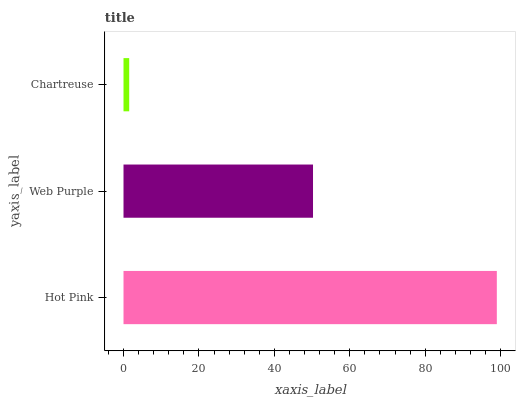Is Chartreuse the minimum?
Answer yes or no. Yes. Is Hot Pink the maximum?
Answer yes or no. Yes. Is Web Purple the minimum?
Answer yes or no. No. Is Web Purple the maximum?
Answer yes or no. No. Is Hot Pink greater than Web Purple?
Answer yes or no. Yes. Is Web Purple less than Hot Pink?
Answer yes or no. Yes. Is Web Purple greater than Hot Pink?
Answer yes or no. No. Is Hot Pink less than Web Purple?
Answer yes or no. No. Is Web Purple the high median?
Answer yes or no. Yes. Is Web Purple the low median?
Answer yes or no. Yes. Is Chartreuse the high median?
Answer yes or no. No. Is Hot Pink the low median?
Answer yes or no. No. 